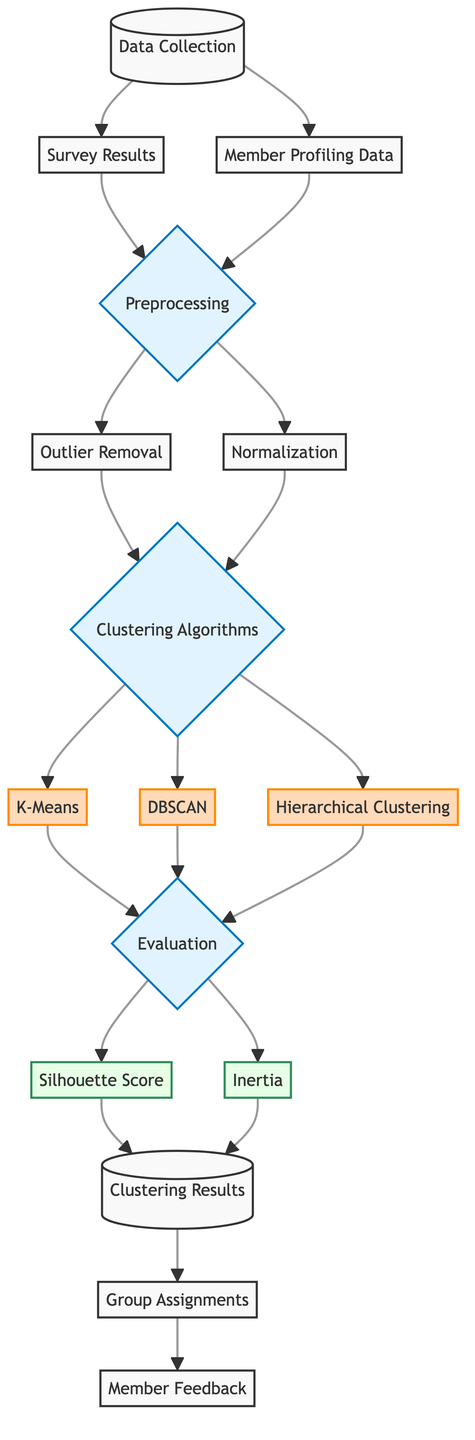What is the first step in the process? The diagram indicates that the first step in the process is "Data Collection," as it is the starting node from which all other processes branch out.
Answer: Data Collection How many clustering algorithms are listed in the diagram? There are three clustering algorithms shown in the diagram: K-Means, DBSCAN, and Hierarchical Clustering. Each algorithm is represented as a separate node connected to the clustering algorithms node.
Answer: Three What does the evaluation step produce? The evaluation step produces two outputs: "Silhouette Score" and "Inertia," as they are the next nodes directly linked to the evaluation step, indicating what metrics will be assessed.
Answer: Silhouette Score and Inertia Which processes occur after preprocessing? After the "Preprocessing" step, the diagram shows two processes: "Outlier Removal" and "Normalization," illustrating the specific steps taken to prepare the data before applying clustering algorithms.
Answer: Outlier Removal and Normalization What type of algorithms are used in the clustering algorithms section? The algorithms listed in the clustering algorithms section are categorized as "Algorithm," which signifies that they are specific approaches used for the clustering process, based on how they group members.
Answer: Algorithm How does member feedback connect to the clustering results? Member feedback is linked to "Group Assignments," which shows that after the clustering results are obtained, group assignments determine how feedback is gathered from members regarding their groups.
Answer: Through Group Assignments Which evaluation metric is associated with the concept of cohesion between clusters? The "Silhouette Score" is the evaluation metric associated with the concept of cohesion, as it measures how similar an object is to its own cluster compared to other clusters.
Answer: Silhouette Score What step follows normalization in the data preprocessing workflow? After "Normalization" within the preprocessing workflow, the next step is to move towards applying "Clustering Algorithms," indicating that the data is ready for analysis following normalization.
Answer: Clustering Algorithms What does the outlier removal step aim to achieve? The "Outlier Removal" step aims to clean the dataset by eliminating data points that do not conform to the general distribution, thereby enhancing the clustering effect.
Answer: Clean the dataset 